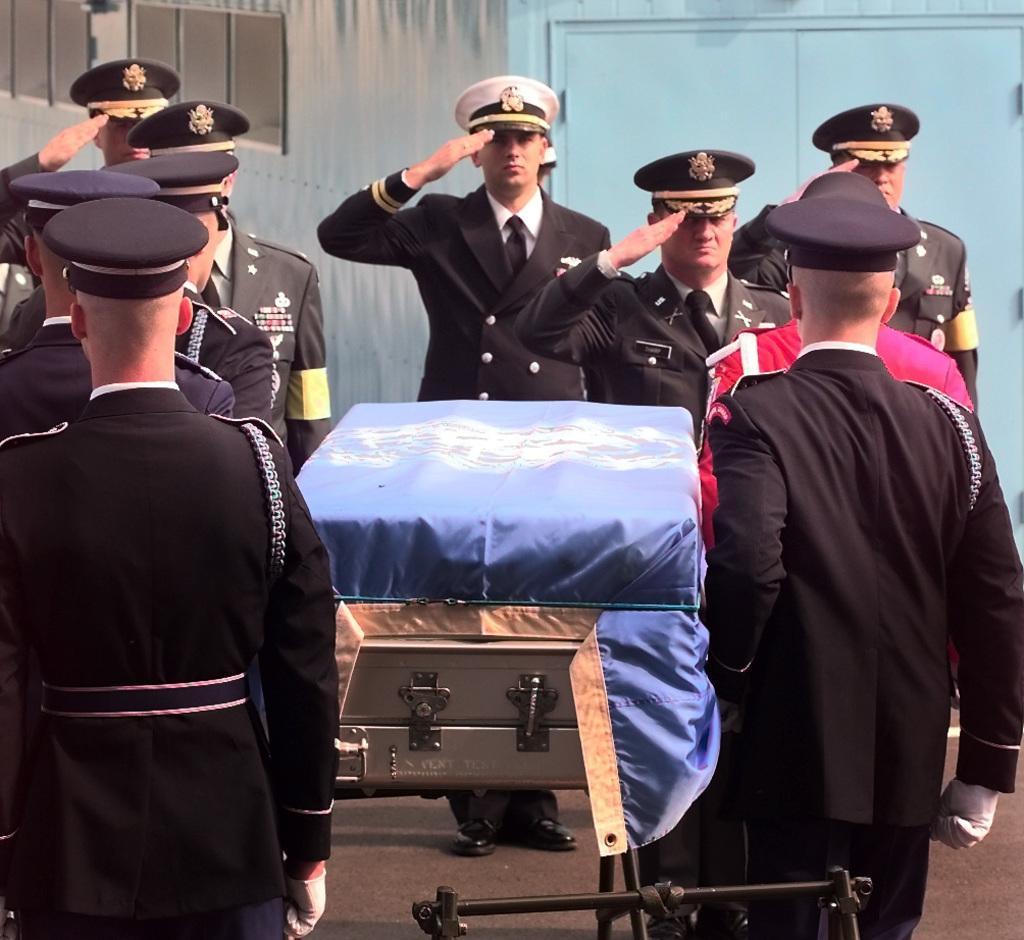Describe this image in one or two sentences. In this image there are few officers paying respect to a deceased officer in duty. Behind them there is a wall. 